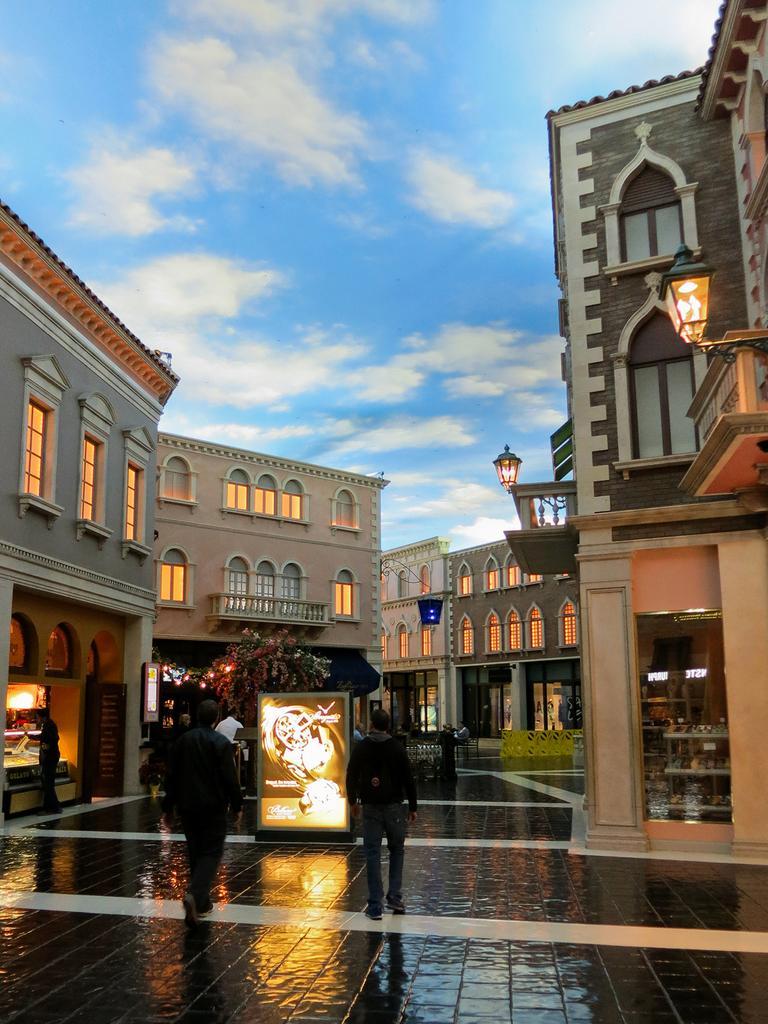In one or two sentences, can you explain what this image depicts? In this image, I can see the buildings with the windows and lights. There are two people walking and few people standing. This looks like a tree. At the top of the image, I can see the clouds in the sky. On the right side of the image, these look like the lamps. 